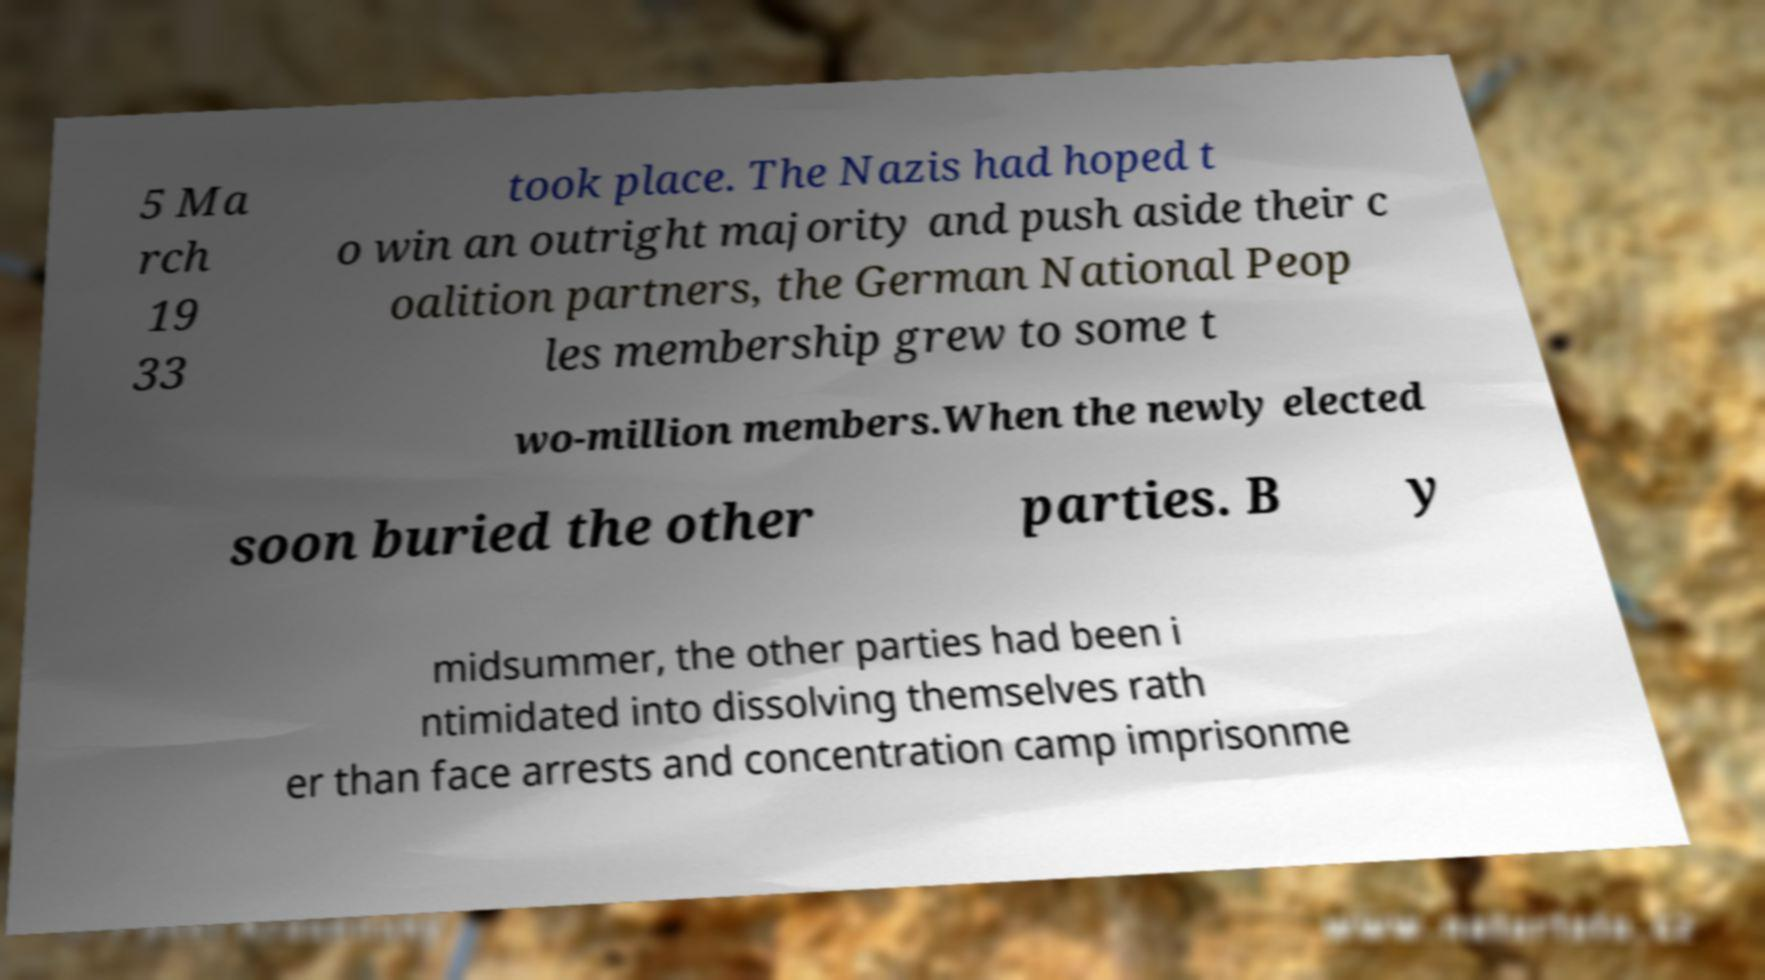Can you accurately transcribe the text from the provided image for me? 5 Ma rch 19 33 took place. The Nazis had hoped t o win an outright majority and push aside their c oalition partners, the German National Peop les membership grew to some t wo-million members.When the newly elected soon buried the other parties. B y midsummer, the other parties had been i ntimidated into dissolving themselves rath er than face arrests and concentration camp imprisonme 